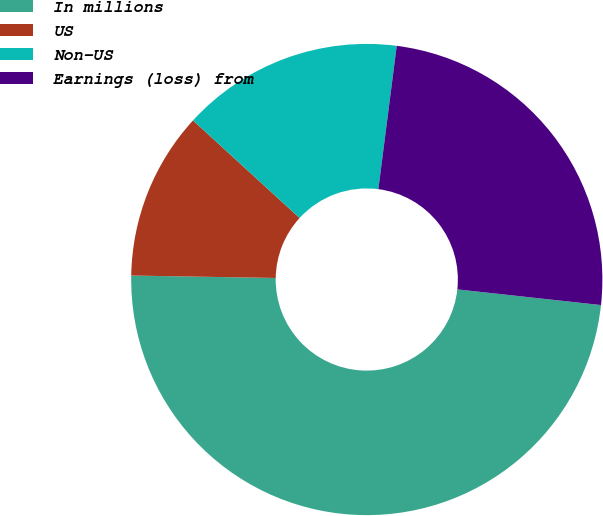Convert chart to OTSL. <chart><loc_0><loc_0><loc_500><loc_500><pie_chart><fcel>In millions<fcel>US<fcel>Non-US<fcel>Earnings (loss) from<nl><fcel>48.54%<fcel>11.53%<fcel>15.23%<fcel>24.7%<nl></chart> 